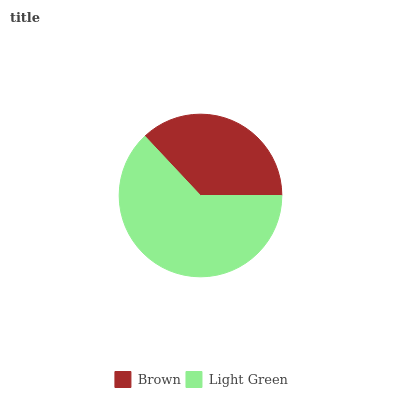Is Brown the minimum?
Answer yes or no. Yes. Is Light Green the maximum?
Answer yes or no. Yes. Is Light Green the minimum?
Answer yes or no. No. Is Light Green greater than Brown?
Answer yes or no. Yes. Is Brown less than Light Green?
Answer yes or no. Yes. Is Brown greater than Light Green?
Answer yes or no. No. Is Light Green less than Brown?
Answer yes or no. No. Is Light Green the high median?
Answer yes or no. Yes. Is Brown the low median?
Answer yes or no. Yes. Is Brown the high median?
Answer yes or no. No. Is Light Green the low median?
Answer yes or no. No. 